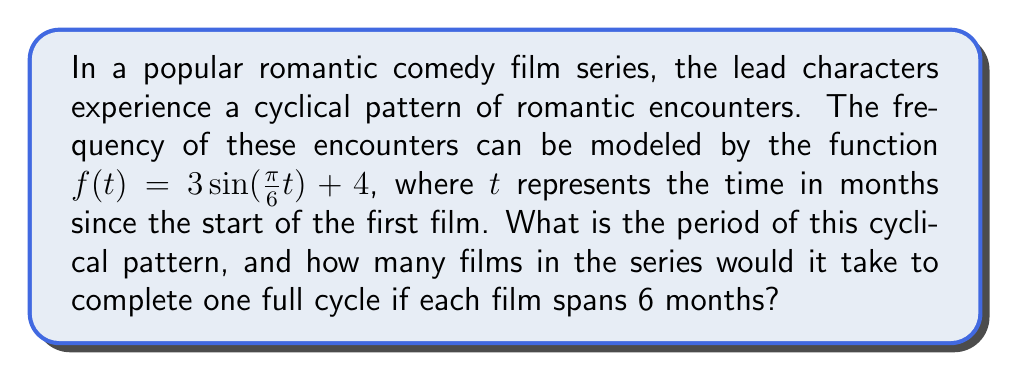Provide a solution to this math problem. To solve this problem, we need to follow these steps:

1) The general form of a sine function is:
   $f(t) = A \sin(Bt) + C$
   where $B$ determines the period of the function.

2) In our case, $B = \frac{\pi}{6}$

3) The period of a sine function is given by the formula:
   $\text{Period} = \frac{2\pi}{|B|}$

4) Substituting our value of $B$:
   $\text{Period} = \frac{2\pi}{|\frac{\pi}{6}|} = \frac{2\pi}{\frac{\pi}{6}} = 2 \cdot 6 = 12$

5) Therefore, the period of the cyclical pattern is 12 months.

6) To determine how many films it would take to complete one cycle:
   - Each film spans 6 months
   - One complete cycle is 12 months
   - Number of films = $\frac{12 \text{ months}}{6 \text{ months per film}} = 2$ films

Thus, it would take 2 films to complete one full cycle of romantic encounters.
Answer: The period of the cyclical pattern is 12 months, and it would take 2 films to complete one full cycle. 